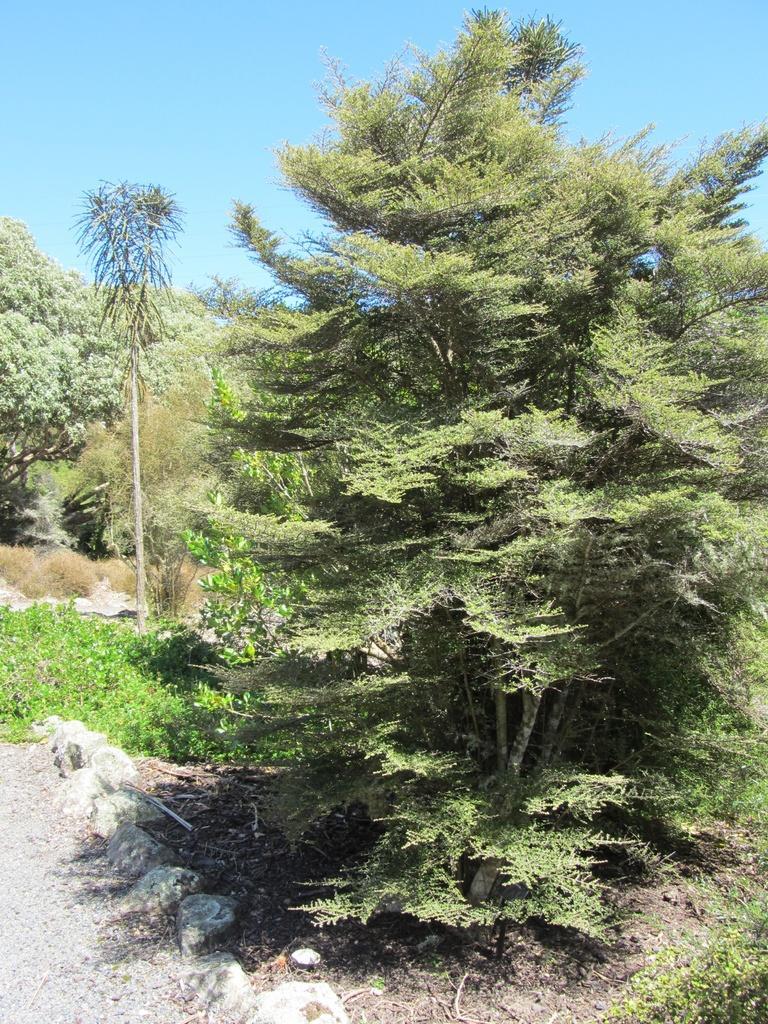How would you summarize this image in a sentence or two? There is a lot of greenery with grass, plants and tall trees and on the left side there is a cement land. 